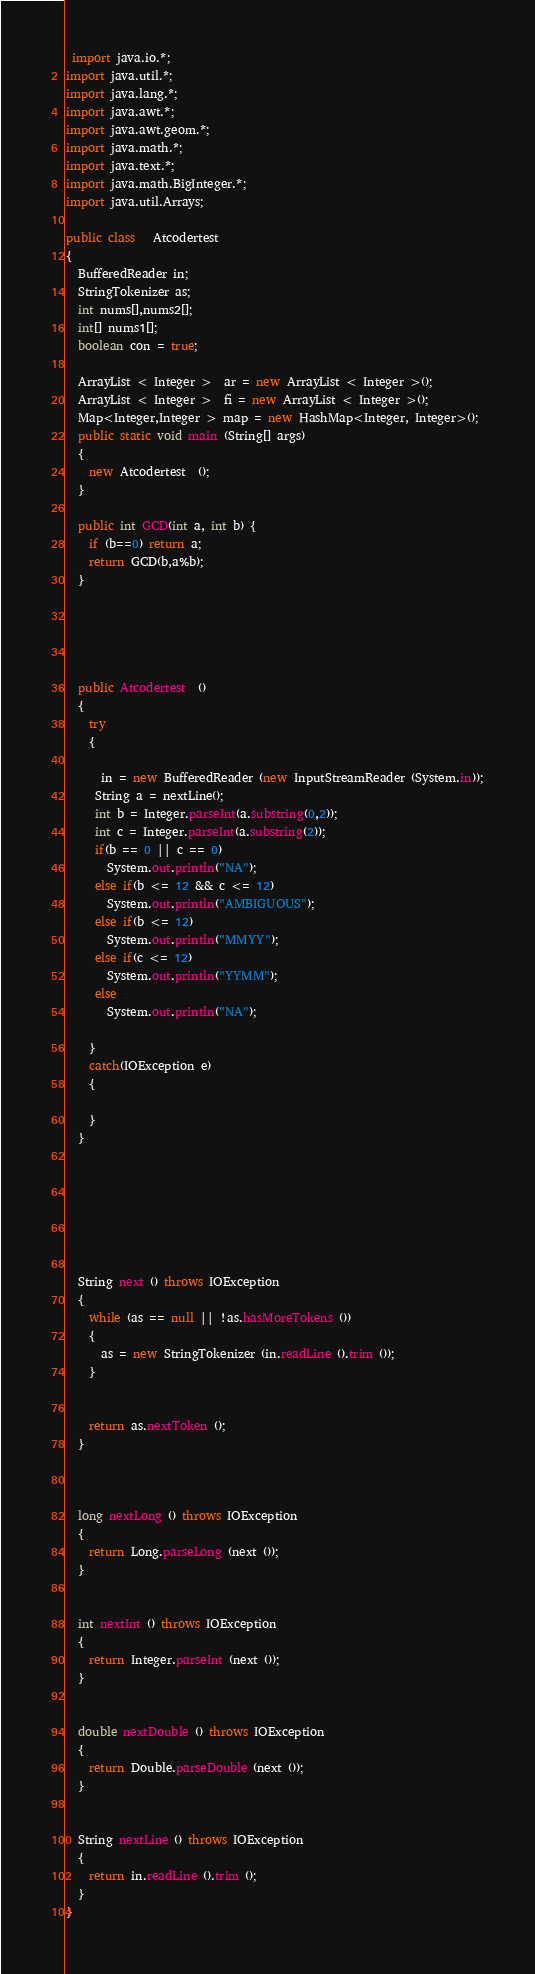Convert code to text. <code><loc_0><loc_0><loc_500><loc_500><_Java_> import java.io.*;
import java.util.*;
import java.lang.*;
import java.awt.*;
import java.awt.geom.*;
import java.math.*;
import java.text.*;
import java.math.BigInteger.*;
import java.util.Arrays; 

public class   Atcodertest
{
  BufferedReader in;
  StringTokenizer as;
  int nums[],nums2[];
  int[] nums1[];
  boolean con = true;
 
  ArrayList < Integer >  ar = new ArrayList < Integer >();
  ArrayList < Integer >  fi = new ArrayList < Integer >();
  Map<Integer,Integer > map = new HashMap<Integer, Integer>();
  public static void main (String[] args)
  {
    new Atcodertest  ();
  }
  
  public int GCD(int a, int b) {
    if (b==0) return a;
    return GCD(b,a%b);
  }
  
  
  
  
  
  public Atcodertest  ()
  {
    try
    {
      
      in = new BufferedReader (new InputStreamReader (System.in));
     String a = nextLine();
     int b = Integer.parseInt(a.substring(0,2));
     int c = Integer.parseInt(a.substring(2));
     if(b == 0 || c == 0)
       System.out.println("NA");
     else if(b <= 12 && c <= 12)
       System.out.println("AMBIGUOUS");
     else if(b <= 12)
       System.out.println("MMYY");
     else if(c <= 12)
       System.out.println("YYMM");
     else
       System.out.println("NA");
      
    }
    catch(IOException e)
    {

    }
  }
  
  
  
  
  
  
  
  String next () throws IOException
  {
    while (as == null || !as.hasMoreTokens ())
    {
      as = new StringTokenizer (in.readLine ().trim ());
    }
    
    
    return as.nextToken ();
  }
  
  
  
  long nextLong () throws IOException
  {
    return Long.parseLong (next ());
  }
  
  
  int nextInt () throws IOException
  {
    return Integer.parseInt (next ());
  }
  
  
  double nextDouble () throws IOException
  {
    return Double.parseDouble (next ());
  }
  
  
  String nextLine () throws IOException
  {
    return in.readLine ().trim ();
  }
}</code> 